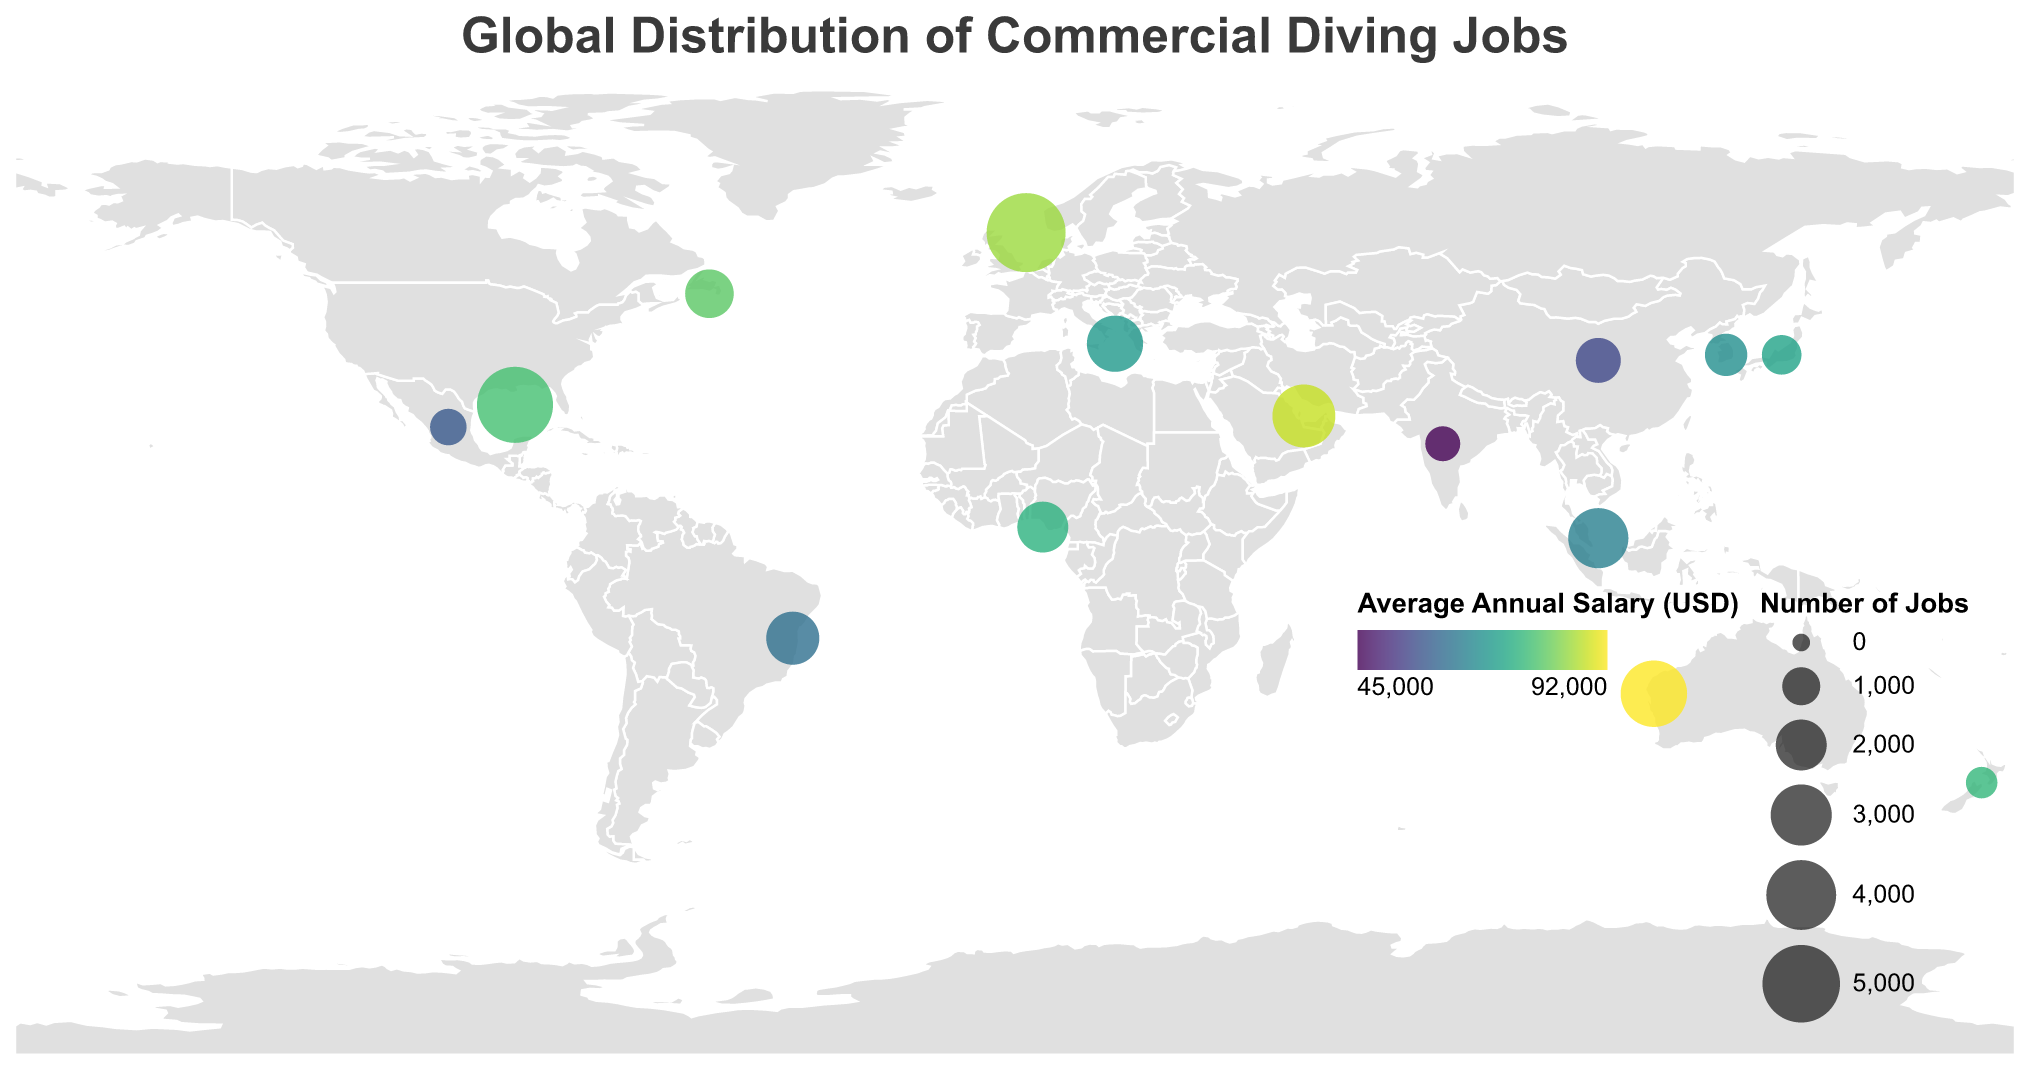How many regions are depicted on the map? Count the number of distinct regions listed in the tooltip data. There are 15 regions mentioned.
Answer: 15 What is the title of the figure? The title of the figure is displayed at the top center of the chart.
Answer: Global Distribution of Commercial Diving Jobs Which region has the highest number of commercial diving jobs? The "Job_Count" column shows the highest value for the North Sea (UK/Norway) region.
Answer: North Sea (UK/Norway) What is the average annual salary in Brazil? Look at the tooltip data for Brazil. The "Average_Annual_Salary_USD" column shows the salary value.
Answer: 62000 USD What is the average salary difference between Western Australia and Southeast Asia? Subtract the average annual salary of Southeast Asia from that of Western Australia: 92000 - 65000 = 27000 USD.
Answer: 27000 USD Which region has the lowest average annual salary? The "Average_Annual_Salary_USD" column points to India as having the lowest salary.
Answer: India What are the longitude and latitude coordinates used to place the circle for the Gulf of Mexico (USA)? The tooltip data gives the "lat" and "lon" values for the Gulf of Mexico (USA).
Answer: Latitude 27, Longitude -90 Compare the average annual salaries between Japan and South Korea. Which is higher? Look at the "Average_Annual_Salary_USD" column: Japan has 72000 USD, while South Korea has 68000 USD. Japan's salary is higher.
Answer: Japan Rank the top three regions in terms of average salary. By sorting the "Average_Annual_Salary_USD" column, the top three regions are Western Australia (92000 USD), Middle East (UAE/Qatar) (88000 USD), and North Sea (UK/Norway) (85000 USD).
Answer: 1. Western Australia, 2. Middle East (UAE/Qatar), 3. North Sea (UK/Norway) What is the approximate region (in terms of map location, not the exact coordinates) with the circle that's largest in size but not the highest in salary? The largest size circle corresponds to the highest "Job_Count", but examining the second largest circle and its properties shows the Gulf of Mexico (USA) which has a significant number of jobs but not the highest salary.
Answer: Gulf of Mexico (USA) 